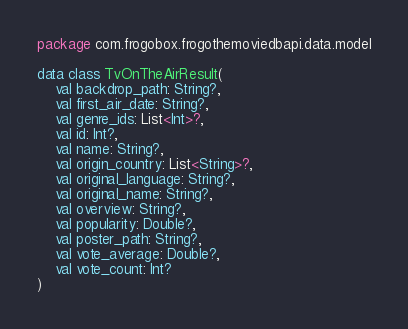Convert code to text. <code><loc_0><loc_0><loc_500><loc_500><_Kotlin_>package com.frogobox.frogothemoviedbapi.data.model

data class TvOnTheAirResult(
    val backdrop_path: String?,
    val first_air_date: String?,
    val genre_ids: List<Int>?,
    val id: Int?,
    val name: String?,
    val origin_country: List<String>?,
    val original_language: String?,
    val original_name: String?,
    val overview: String?,
    val popularity: Double?,
    val poster_path: String?,
    val vote_average: Double?,
    val vote_count: Int?
)</code> 